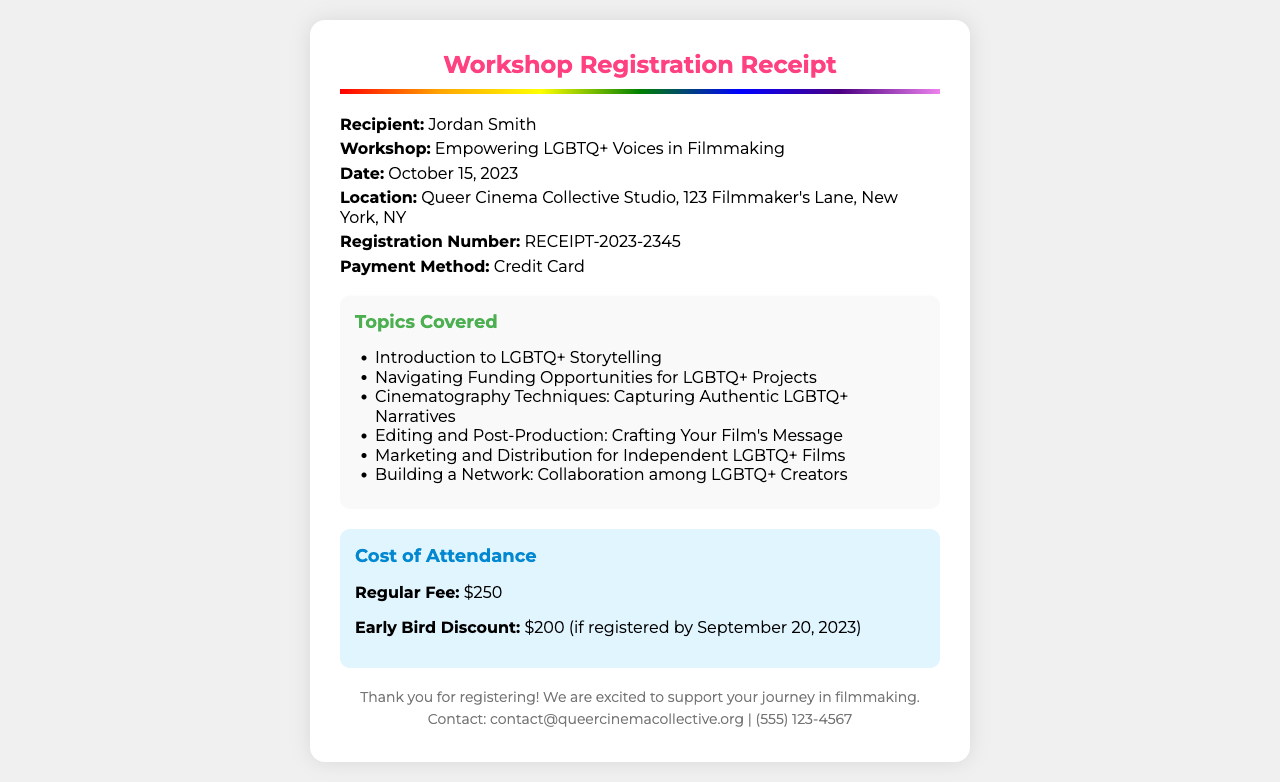What is the recipient's name? The recipient's name is mentioned in the information section of the receipt.
Answer: Jordan Smith What is the title of the workshop? The workshop title is located in the information section.
Answer: Empowering LGBTQ+ Voices in Filmmaking When is the workshop scheduled? The date of the workshop can be found in the information section.
Answer: October 15, 2023 What is the location of the workshop? The location is specified in the information section of the receipt.
Answer: Queer Cinema Collective Studio, 123 Filmmaker's Lane, New York, NY What is the registration number? The registration number is provided in the information section of the receipt.
Answer: RECEIPT-2023-2345 What is the regular fee for the workshop? The regular fee is listed in the cost section of the receipt.
Answer: $250 What is the early bird discount price? The early bird discount is mentioned in the cost section of the receipt.
Answer: $200 How many topics are covered in the workshop? The number of topics covered can be determined by counting the list in the topics section.
Answer: 6 Which topic focuses on funding opportunities? The specific topic related to funding opportunities is listed in the topics section.
Answer: Navigating Funding Opportunities for LGBTQ+ Projects 